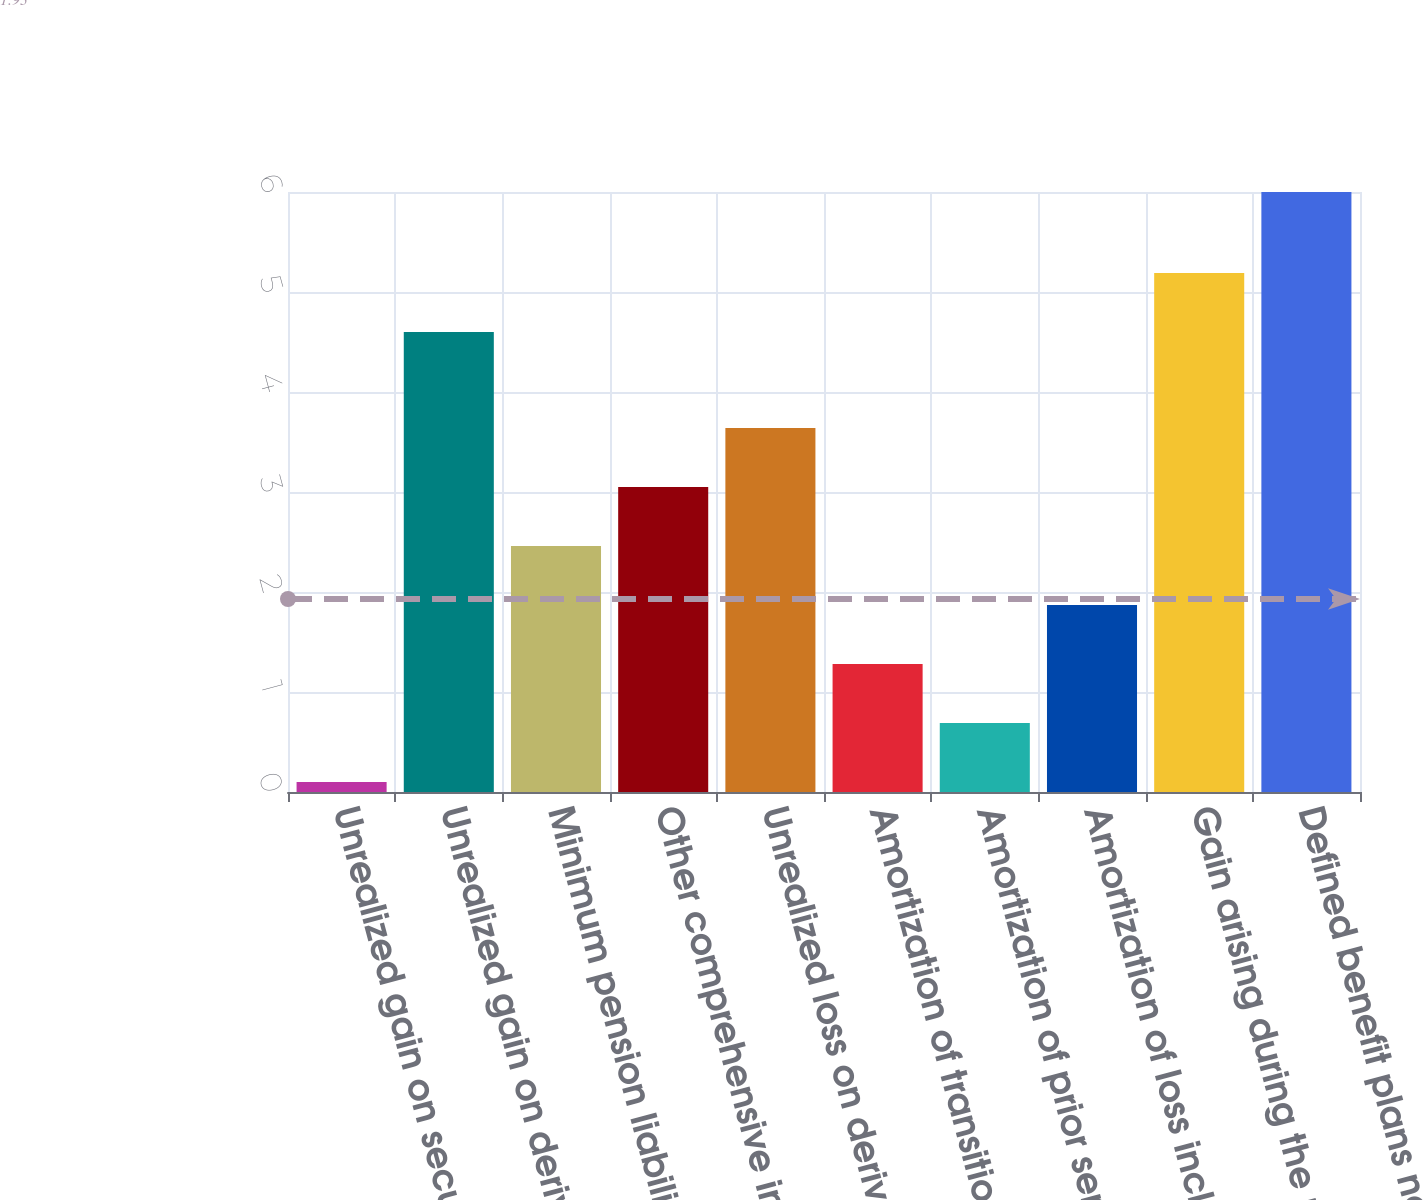<chart> <loc_0><loc_0><loc_500><loc_500><bar_chart><fcel>Unrealized gain on securities<fcel>Unrealized gain on derivatives<fcel>Minimum pension liability<fcel>Other comprehensive income<fcel>Unrealized loss on derivatives<fcel>Amortization of transition<fcel>Amortization of prior service<fcel>Amortization of loss included<fcel>Gain arising during the period<fcel>Defined benefit plans net<nl><fcel>0.1<fcel>4.6<fcel>2.46<fcel>3.05<fcel>3.64<fcel>1.28<fcel>0.69<fcel>1.87<fcel>5.19<fcel>6<nl></chart> 